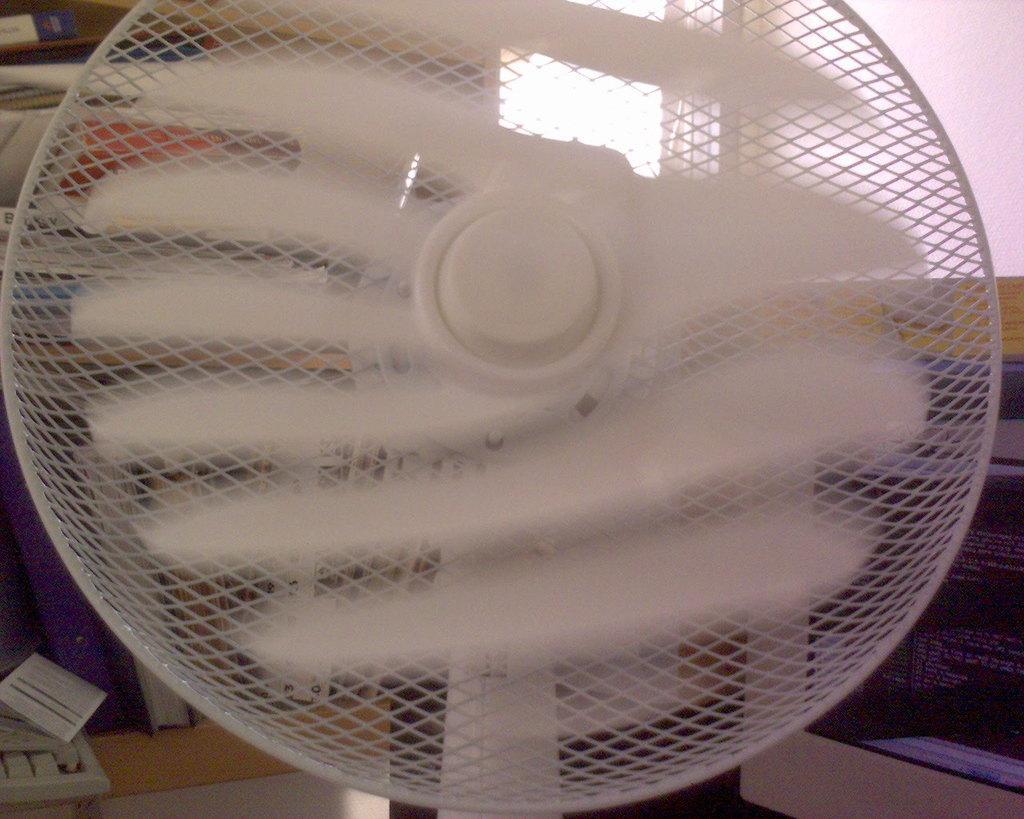How would you summarize this image in a sentence or two? In this image in the foreground there is one fan, and in the background there is computer, keyboard, window, wall and some other objects. 